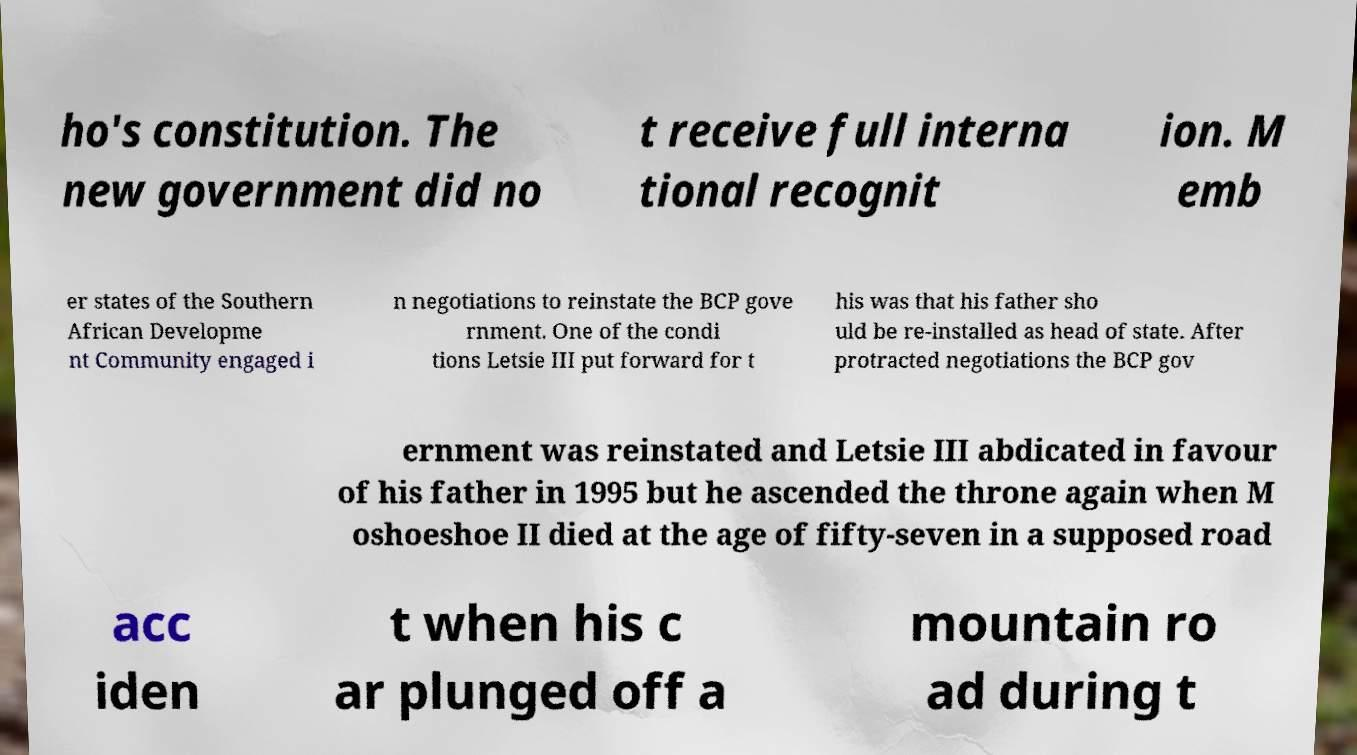I need the written content from this picture converted into text. Can you do that? ho's constitution. The new government did no t receive full interna tional recognit ion. M emb er states of the Southern African Developme nt Community engaged i n negotiations to reinstate the BCP gove rnment. One of the condi tions Letsie III put forward for t his was that his father sho uld be re-installed as head of state. After protracted negotiations the BCP gov ernment was reinstated and Letsie III abdicated in favour of his father in 1995 but he ascended the throne again when M oshoeshoe II died at the age of fifty-seven in a supposed road acc iden t when his c ar plunged off a mountain ro ad during t 